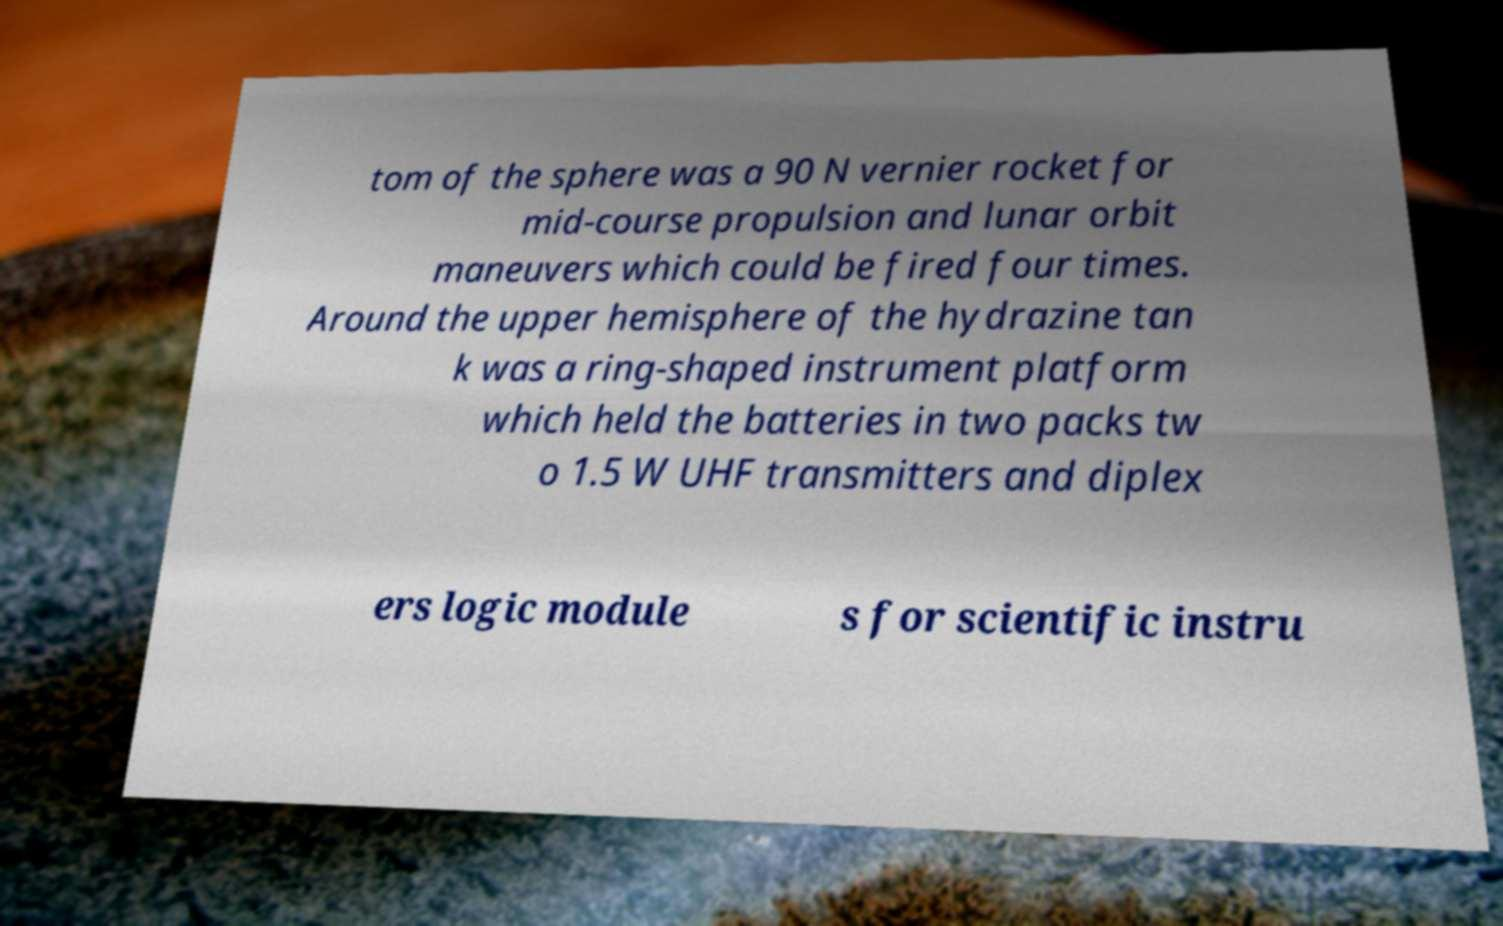Could you extract and type out the text from this image? tom of the sphere was a 90 N vernier rocket for mid-course propulsion and lunar orbit maneuvers which could be fired four times. Around the upper hemisphere of the hydrazine tan k was a ring-shaped instrument platform which held the batteries in two packs tw o 1.5 W UHF transmitters and diplex ers logic module s for scientific instru 